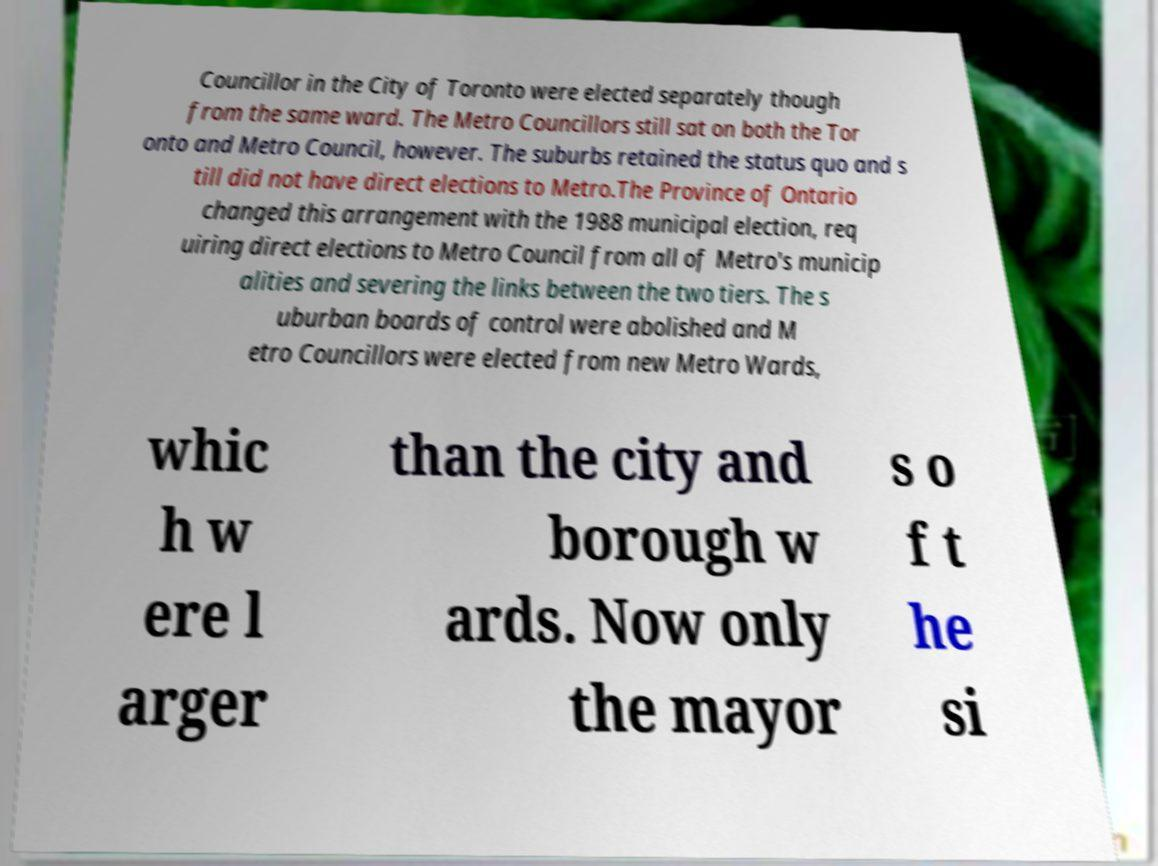Please read and relay the text visible in this image. What does it say? Councillor in the City of Toronto were elected separately though from the same ward. The Metro Councillors still sat on both the Tor onto and Metro Council, however. The suburbs retained the status quo and s till did not have direct elections to Metro.The Province of Ontario changed this arrangement with the 1988 municipal election, req uiring direct elections to Metro Council from all of Metro's municip alities and severing the links between the two tiers. The s uburban boards of control were abolished and M etro Councillors were elected from new Metro Wards, whic h w ere l arger than the city and borough w ards. Now only the mayor s o f t he si 